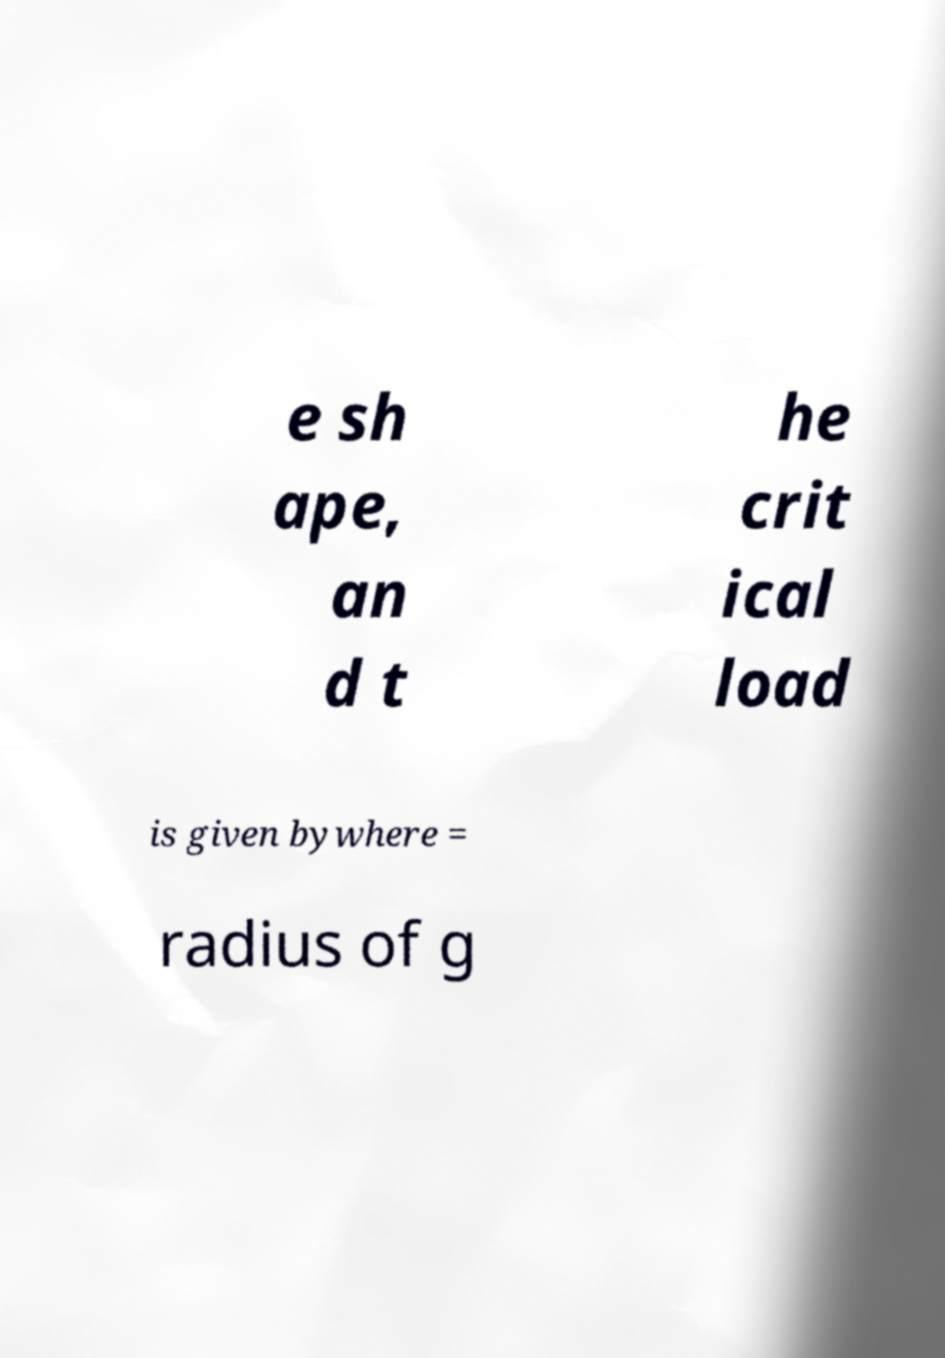What messages or text are displayed in this image? I need them in a readable, typed format. e sh ape, an d t he crit ical load is given bywhere = radius of g 